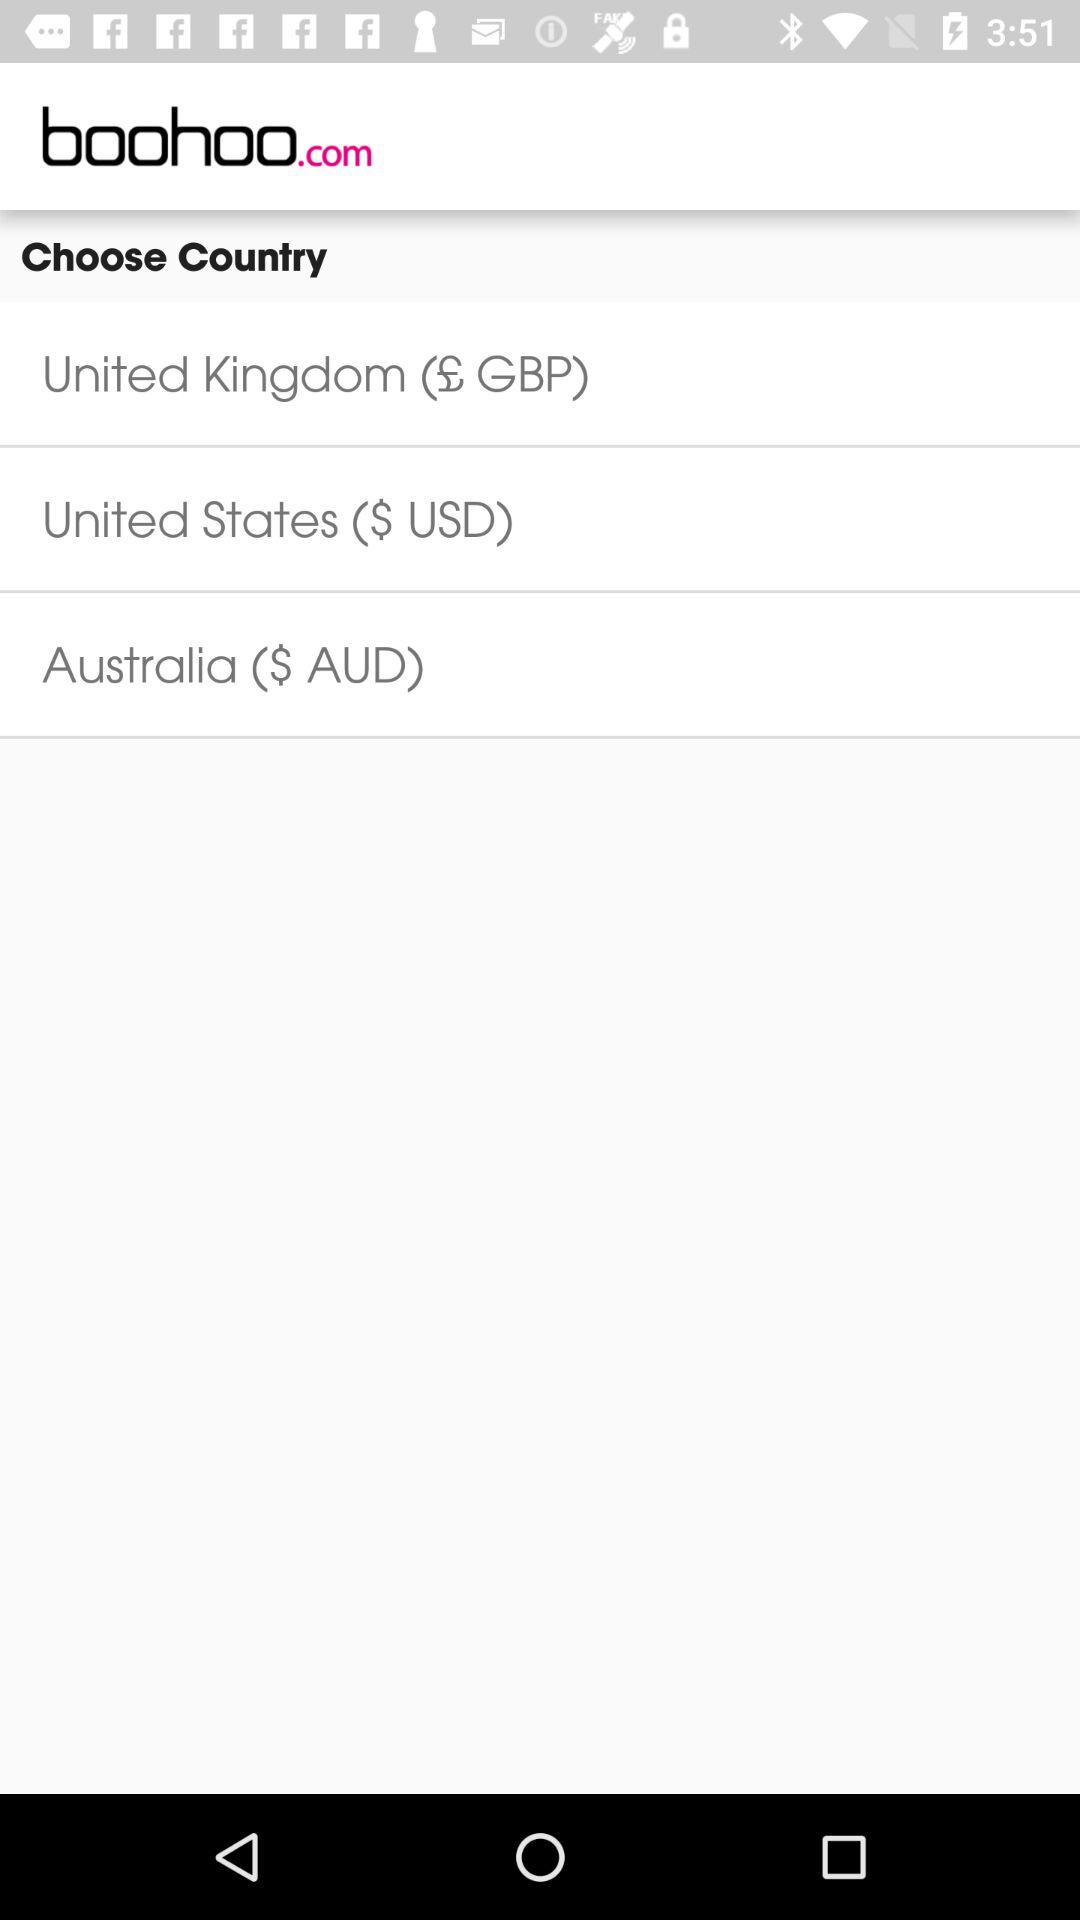How many countries are available to choose from?
Answer the question using a single word or phrase. 3 